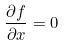Convert formula to latex. <formula><loc_0><loc_0><loc_500><loc_500>\frac { \partial f } { \partial x } = 0</formula> 